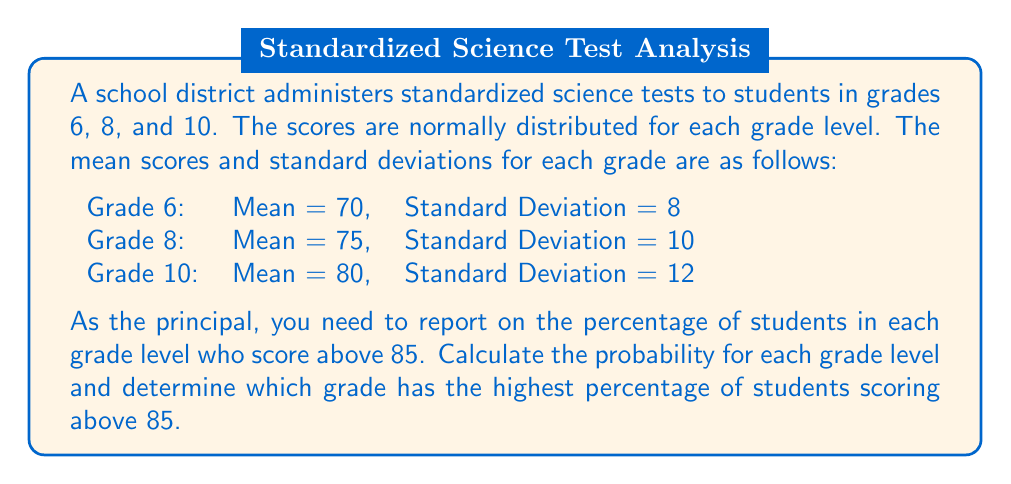Help me with this question. To solve this problem, we'll use the properties of the normal distribution and the z-score formula for each grade level.

1. Calculate the z-score for a score of 85 in each grade:

Grade 6: $z = \frac{x - \mu}{\sigma} = \frac{85 - 70}{8} = 1.875$
Grade 8: $z = \frac{85 - 75}{10} = 1$
Grade 10: $z = \frac{85 - 80}{12} = 0.4167$

2. Use the standard normal distribution table or a calculator to find the probability of scoring above each z-score:

Grade 6: $P(Z > 1.875) = 1 - P(Z < 1.875) = 1 - 0.9696 = 0.0304$ or 3.04%
Grade 8: $P(Z > 1) = 1 - P(Z < 1) = 1 - 0.8413 = 0.1587$ or 15.87%
Grade 10: $P(Z > 0.4167) = 1 - P(Z < 0.4167) = 1 - 0.6616 = 0.3384$ or 33.84%

3. Compare the percentages:

Grade 6: 3.04%
Grade 8: 15.87%
Grade 10: 33.84%

Grade 10 has the highest percentage of students scoring above 85.
Answer: Grade 10 (33.84%) 